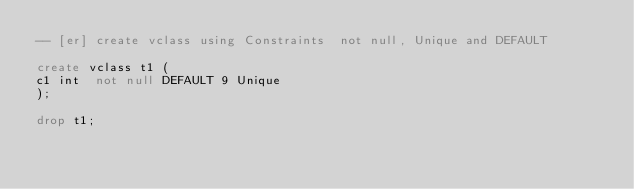<code> <loc_0><loc_0><loc_500><loc_500><_SQL_>-- [er] create vclass using Constraints  not null, Unique and DEFAULT

create vclass t1 (
c1 int  not null DEFAULT 9 Unique
);

drop t1;</code> 